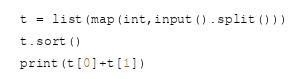<code> <loc_0><loc_0><loc_500><loc_500><_Python_>t = list(map(int,input().split()))

t.sort()

print(t[0]+t[1])</code> 